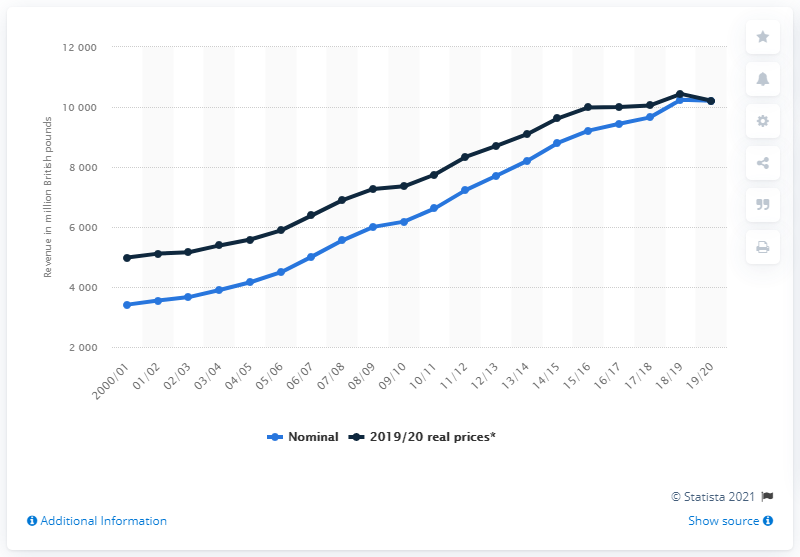Identify some key points in this picture. In the year 2019/20, the total revenue generated by National Rail from passenger fares was 10,208. 